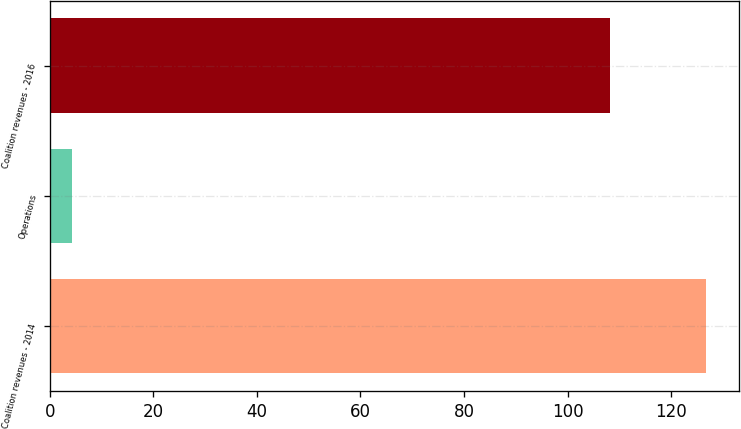Convert chart to OTSL. <chart><loc_0><loc_0><loc_500><loc_500><bar_chart><fcel>Coalition revenues - 2014<fcel>Operations<fcel>Coalition revenues - 2016<nl><fcel>126.7<fcel>4.3<fcel>108.1<nl></chart> 